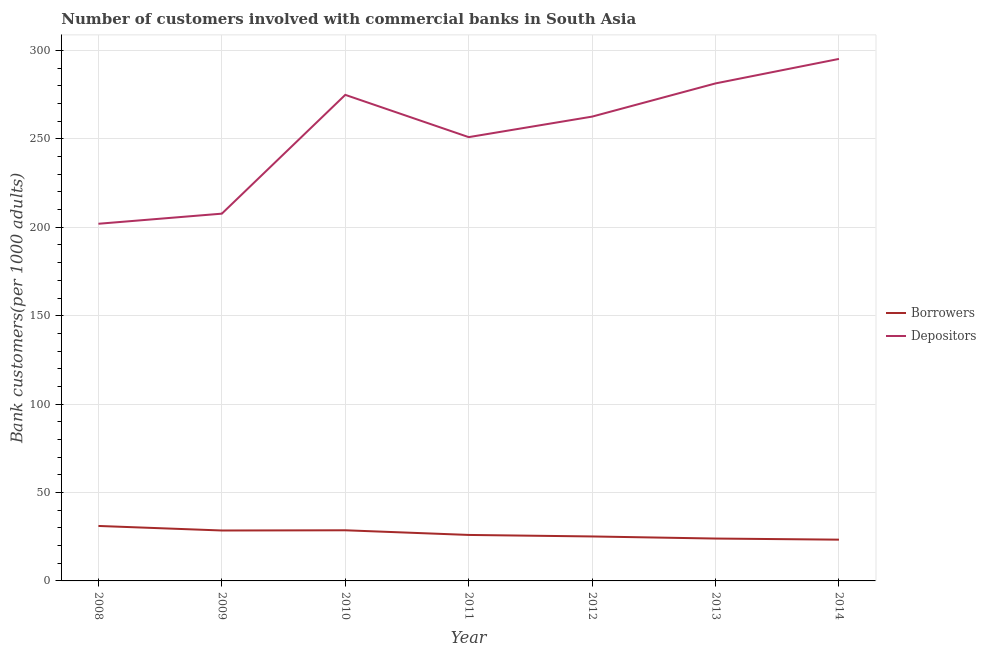How many different coloured lines are there?
Offer a terse response. 2. Is the number of lines equal to the number of legend labels?
Give a very brief answer. Yes. What is the number of borrowers in 2010?
Your answer should be compact. 28.64. Across all years, what is the maximum number of depositors?
Your answer should be compact. 295.23. Across all years, what is the minimum number of borrowers?
Provide a short and direct response. 23.34. In which year was the number of borrowers minimum?
Offer a very short reply. 2014. What is the total number of depositors in the graph?
Your answer should be compact. 1774.82. What is the difference between the number of borrowers in 2009 and that in 2014?
Your response must be concise. 5.18. What is the difference between the number of borrowers in 2011 and the number of depositors in 2014?
Provide a short and direct response. -269.22. What is the average number of borrowers per year?
Provide a short and direct response. 26.67. In the year 2013, what is the difference between the number of borrowers and number of depositors?
Keep it short and to the point. -257.41. What is the ratio of the number of depositors in 2011 to that in 2012?
Give a very brief answer. 0.96. Is the difference between the number of depositors in 2010 and 2012 greater than the difference between the number of borrowers in 2010 and 2012?
Your answer should be very brief. Yes. What is the difference between the highest and the second highest number of depositors?
Make the answer very short. 13.85. What is the difference between the highest and the lowest number of depositors?
Offer a terse response. 93.23. Is the sum of the number of borrowers in 2008 and 2009 greater than the maximum number of depositors across all years?
Keep it short and to the point. No. Is the number of depositors strictly less than the number of borrowers over the years?
Offer a very short reply. No. How many lines are there?
Offer a very short reply. 2. How many years are there in the graph?
Offer a very short reply. 7. How are the legend labels stacked?
Your answer should be compact. Vertical. What is the title of the graph?
Ensure brevity in your answer.  Number of customers involved with commercial banks in South Asia. Does "Male" appear as one of the legend labels in the graph?
Offer a terse response. No. What is the label or title of the Y-axis?
Provide a succinct answer. Bank customers(per 1000 adults). What is the Bank customers(per 1000 adults) in Borrowers in 2008?
Your answer should be compact. 31.09. What is the Bank customers(per 1000 adults) of Depositors in 2008?
Provide a short and direct response. 202. What is the Bank customers(per 1000 adults) of Borrowers in 2009?
Make the answer very short. 28.52. What is the Bank customers(per 1000 adults) of Depositors in 2009?
Your response must be concise. 207.71. What is the Bank customers(per 1000 adults) of Borrowers in 2010?
Offer a very short reply. 28.64. What is the Bank customers(per 1000 adults) in Depositors in 2010?
Provide a succinct answer. 274.9. What is the Bank customers(per 1000 adults) in Borrowers in 2011?
Offer a very short reply. 26.01. What is the Bank customers(per 1000 adults) in Depositors in 2011?
Offer a very short reply. 250.99. What is the Bank customers(per 1000 adults) of Borrowers in 2012?
Provide a short and direct response. 25.15. What is the Bank customers(per 1000 adults) of Depositors in 2012?
Your answer should be very brief. 262.6. What is the Bank customers(per 1000 adults) of Borrowers in 2013?
Make the answer very short. 23.97. What is the Bank customers(per 1000 adults) in Depositors in 2013?
Provide a succinct answer. 281.38. What is the Bank customers(per 1000 adults) in Borrowers in 2014?
Keep it short and to the point. 23.34. What is the Bank customers(per 1000 adults) of Depositors in 2014?
Ensure brevity in your answer.  295.23. Across all years, what is the maximum Bank customers(per 1000 adults) of Borrowers?
Give a very brief answer. 31.09. Across all years, what is the maximum Bank customers(per 1000 adults) in Depositors?
Ensure brevity in your answer.  295.23. Across all years, what is the minimum Bank customers(per 1000 adults) in Borrowers?
Ensure brevity in your answer.  23.34. Across all years, what is the minimum Bank customers(per 1000 adults) of Depositors?
Offer a very short reply. 202. What is the total Bank customers(per 1000 adults) in Borrowers in the graph?
Your response must be concise. 186.72. What is the total Bank customers(per 1000 adults) of Depositors in the graph?
Offer a very short reply. 1774.82. What is the difference between the Bank customers(per 1000 adults) in Borrowers in 2008 and that in 2009?
Offer a very short reply. 2.57. What is the difference between the Bank customers(per 1000 adults) of Depositors in 2008 and that in 2009?
Keep it short and to the point. -5.71. What is the difference between the Bank customers(per 1000 adults) of Borrowers in 2008 and that in 2010?
Provide a short and direct response. 2.45. What is the difference between the Bank customers(per 1000 adults) of Depositors in 2008 and that in 2010?
Your response must be concise. -72.91. What is the difference between the Bank customers(per 1000 adults) of Borrowers in 2008 and that in 2011?
Keep it short and to the point. 5.08. What is the difference between the Bank customers(per 1000 adults) of Depositors in 2008 and that in 2011?
Your response must be concise. -49. What is the difference between the Bank customers(per 1000 adults) of Borrowers in 2008 and that in 2012?
Your answer should be very brief. 5.94. What is the difference between the Bank customers(per 1000 adults) in Depositors in 2008 and that in 2012?
Your answer should be compact. -60.6. What is the difference between the Bank customers(per 1000 adults) of Borrowers in 2008 and that in 2013?
Ensure brevity in your answer.  7.13. What is the difference between the Bank customers(per 1000 adults) of Depositors in 2008 and that in 2013?
Offer a terse response. -79.38. What is the difference between the Bank customers(per 1000 adults) in Borrowers in 2008 and that in 2014?
Your answer should be compact. 7.75. What is the difference between the Bank customers(per 1000 adults) in Depositors in 2008 and that in 2014?
Provide a succinct answer. -93.23. What is the difference between the Bank customers(per 1000 adults) of Borrowers in 2009 and that in 2010?
Your answer should be compact. -0.12. What is the difference between the Bank customers(per 1000 adults) of Depositors in 2009 and that in 2010?
Keep it short and to the point. -67.19. What is the difference between the Bank customers(per 1000 adults) of Borrowers in 2009 and that in 2011?
Keep it short and to the point. 2.51. What is the difference between the Bank customers(per 1000 adults) of Depositors in 2009 and that in 2011?
Give a very brief answer. -43.28. What is the difference between the Bank customers(per 1000 adults) in Borrowers in 2009 and that in 2012?
Offer a very short reply. 3.37. What is the difference between the Bank customers(per 1000 adults) in Depositors in 2009 and that in 2012?
Keep it short and to the point. -54.89. What is the difference between the Bank customers(per 1000 adults) of Borrowers in 2009 and that in 2013?
Give a very brief answer. 4.55. What is the difference between the Bank customers(per 1000 adults) of Depositors in 2009 and that in 2013?
Your answer should be compact. -73.67. What is the difference between the Bank customers(per 1000 adults) in Borrowers in 2009 and that in 2014?
Offer a terse response. 5.18. What is the difference between the Bank customers(per 1000 adults) in Depositors in 2009 and that in 2014?
Provide a succinct answer. -87.52. What is the difference between the Bank customers(per 1000 adults) of Borrowers in 2010 and that in 2011?
Make the answer very short. 2.63. What is the difference between the Bank customers(per 1000 adults) in Depositors in 2010 and that in 2011?
Provide a succinct answer. 23.91. What is the difference between the Bank customers(per 1000 adults) in Borrowers in 2010 and that in 2012?
Your answer should be very brief. 3.49. What is the difference between the Bank customers(per 1000 adults) in Depositors in 2010 and that in 2012?
Keep it short and to the point. 12.31. What is the difference between the Bank customers(per 1000 adults) in Borrowers in 2010 and that in 2013?
Your answer should be very brief. 4.68. What is the difference between the Bank customers(per 1000 adults) of Depositors in 2010 and that in 2013?
Give a very brief answer. -6.48. What is the difference between the Bank customers(per 1000 adults) of Borrowers in 2010 and that in 2014?
Provide a succinct answer. 5.3. What is the difference between the Bank customers(per 1000 adults) in Depositors in 2010 and that in 2014?
Give a very brief answer. -20.33. What is the difference between the Bank customers(per 1000 adults) in Borrowers in 2011 and that in 2012?
Provide a short and direct response. 0.86. What is the difference between the Bank customers(per 1000 adults) in Depositors in 2011 and that in 2012?
Offer a terse response. -11.61. What is the difference between the Bank customers(per 1000 adults) in Borrowers in 2011 and that in 2013?
Your response must be concise. 2.04. What is the difference between the Bank customers(per 1000 adults) in Depositors in 2011 and that in 2013?
Make the answer very short. -30.39. What is the difference between the Bank customers(per 1000 adults) in Borrowers in 2011 and that in 2014?
Ensure brevity in your answer.  2.67. What is the difference between the Bank customers(per 1000 adults) of Depositors in 2011 and that in 2014?
Provide a short and direct response. -44.24. What is the difference between the Bank customers(per 1000 adults) of Borrowers in 2012 and that in 2013?
Keep it short and to the point. 1.18. What is the difference between the Bank customers(per 1000 adults) in Depositors in 2012 and that in 2013?
Provide a short and direct response. -18.78. What is the difference between the Bank customers(per 1000 adults) in Borrowers in 2012 and that in 2014?
Your response must be concise. 1.81. What is the difference between the Bank customers(per 1000 adults) in Depositors in 2012 and that in 2014?
Make the answer very short. -32.63. What is the difference between the Bank customers(per 1000 adults) of Borrowers in 2013 and that in 2014?
Provide a succinct answer. 0.63. What is the difference between the Bank customers(per 1000 adults) of Depositors in 2013 and that in 2014?
Offer a terse response. -13.85. What is the difference between the Bank customers(per 1000 adults) in Borrowers in 2008 and the Bank customers(per 1000 adults) in Depositors in 2009?
Ensure brevity in your answer.  -176.62. What is the difference between the Bank customers(per 1000 adults) in Borrowers in 2008 and the Bank customers(per 1000 adults) in Depositors in 2010?
Your answer should be very brief. -243.81. What is the difference between the Bank customers(per 1000 adults) of Borrowers in 2008 and the Bank customers(per 1000 adults) of Depositors in 2011?
Your response must be concise. -219.9. What is the difference between the Bank customers(per 1000 adults) of Borrowers in 2008 and the Bank customers(per 1000 adults) of Depositors in 2012?
Give a very brief answer. -231.51. What is the difference between the Bank customers(per 1000 adults) of Borrowers in 2008 and the Bank customers(per 1000 adults) of Depositors in 2013?
Give a very brief answer. -250.29. What is the difference between the Bank customers(per 1000 adults) in Borrowers in 2008 and the Bank customers(per 1000 adults) in Depositors in 2014?
Offer a terse response. -264.14. What is the difference between the Bank customers(per 1000 adults) in Borrowers in 2009 and the Bank customers(per 1000 adults) in Depositors in 2010?
Your answer should be very brief. -246.38. What is the difference between the Bank customers(per 1000 adults) of Borrowers in 2009 and the Bank customers(per 1000 adults) of Depositors in 2011?
Give a very brief answer. -222.47. What is the difference between the Bank customers(per 1000 adults) in Borrowers in 2009 and the Bank customers(per 1000 adults) in Depositors in 2012?
Provide a succinct answer. -234.08. What is the difference between the Bank customers(per 1000 adults) in Borrowers in 2009 and the Bank customers(per 1000 adults) in Depositors in 2013?
Make the answer very short. -252.86. What is the difference between the Bank customers(per 1000 adults) of Borrowers in 2009 and the Bank customers(per 1000 adults) of Depositors in 2014?
Make the answer very short. -266.71. What is the difference between the Bank customers(per 1000 adults) of Borrowers in 2010 and the Bank customers(per 1000 adults) of Depositors in 2011?
Provide a succinct answer. -222.35. What is the difference between the Bank customers(per 1000 adults) in Borrowers in 2010 and the Bank customers(per 1000 adults) in Depositors in 2012?
Give a very brief answer. -233.96. What is the difference between the Bank customers(per 1000 adults) of Borrowers in 2010 and the Bank customers(per 1000 adults) of Depositors in 2013?
Your answer should be compact. -252.74. What is the difference between the Bank customers(per 1000 adults) in Borrowers in 2010 and the Bank customers(per 1000 adults) in Depositors in 2014?
Offer a very short reply. -266.59. What is the difference between the Bank customers(per 1000 adults) of Borrowers in 2011 and the Bank customers(per 1000 adults) of Depositors in 2012?
Provide a succinct answer. -236.59. What is the difference between the Bank customers(per 1000 adults) of Borrowers in 2011 and the Bank customers(per 1000 adults) of Depositors in 2013?
Provide a succinct answer. -255.37. What is the difference between the Bank customers(per 1000 adults) of Borrowers in 2011 and the Bank customers(per 1000 adults) of Depositors in 2014?
Offer a very short reply. -269.22. What is the difference between the Bank customers(per 1000 adults) of Borrowers in 2012 and the Bank customers(per 1000 adults) of Depositors in 2013?
Ensure brevity in your answer.  -256.23. What is the difference between the Bank customers(per 1000 adults) in Borrowers in 2012 and the Bank customers(per 1000 adults) in Depositors in 2014?
Make the answer very short. -270.08. What is the difference between the Bank customers(per 1000 adults) in Borrowers in 2013 and the Bank customers(per 1000 adults) in Depositors in 2014?
Ensure brevity in your answer.  -271.27. What is the average Bank customers(per 1000 adults) of Borrowers per year?
Keep it short and to the point. 26.67. What is the average Bank customers(per 1000 adults) in Depositors per year?
Provide a succinct answer. 253.55. In the year 2008, what is the difference between the Bank customers(per 1000 adults) in Borrowers and Bank customers(per 1000 adults) in Depositors?
Keep it short and to the point. -170.91. In the year 2009, what is the difference between the Bank customers(per 1000 adults) in Borrowers and Bank customers(per 1000 adults) in Depositors?
Provide a succinct answer. -179.19. In the year 2010, what is the difference between the Bank customers(per 1000 adults) of Borrowers and Bank customers(per 1000 adults) of Depositors?
Give a very brief answer. -246.26. In the year 2011, what is the difference between the Bank customers(per 1000 adults) of Borrowers and Bank customers(per 1000 adults) of Depositors?
Make the answer very short. -224.98. In the year 2012, what is the difference between the Bank customers(per 1000 adults) of Borrowers and Bank customers(per 1000 adults) of Depositors?
Keep it short and to the point. -237.45. In the year 2013, what is the difference between the Bank customers(per 1000 adults) of Borrowers and Bank customers(per 1000 adults) of Depositors?
Keep it short and to the point. -257.41. In the year 2014, what is the difference between the Bank customers(per 1000 adults) of Borrowers and Bank customers(per 1000 adults) of Depositors?
Offer a very short reply. -271.89. What is the ratio of the Bank customers(per 1000 adults) in Borrowers in 2008 to that in 2009?
Provide a short and direct response. 1.09. What is the ratio of the Bank customers(per 1000 adults) in Depositors in 2008 to that in 2009?
Provide a succinct answer. 0.97. What is the ratio of the Bank customers(per 1000 adults) in Borrowers in 2008 to that in 2010?
Provide a short and direct response. 1.09. What is the ratio of the Bank customers(per 1000 adults) of Depositors in 2008 to that in 2010?
Your response must be concise. 0.73. What is the ratio of the Bank customers(per 1000 adults) of Borrowers in 2008 to that in 2011?
Keep it short and to the point. 1.2. What is the ratio of the Bank customers(per 1000 adults) in Depositors in 2008 to that in 2011?
Provide a short and direct response. 0.8. What is the ratio of the Bank customers(per 1000 adults) in Borrowers in 2008 to that in 2012?
Offer a very short reply. 1.24. What is the ratio of the Bank customers(per 1000 adults) of Depositors in 2008 to that in 2012?
Ensure brevity in your answer.  0.77. What is the ratio of the Bank customers(per 1000 adults) of Borrowers in 2008 to that in 2013?
Provide a short and direct response. 1.3. What is the ratio of the Bank customers(per 1000 adults) in Depositors in 2008 to that in 2013?
Offer a terse response. 0.72. What is the ratio of the Bank customers(per 1000 adults) of Borrowers in 2008 to that in 2014?
Offer a very short reply. 1.33. What is the ratio of the Bank customers(per 1000 adults) in Depositors in 2008 to that in 2014?
Provide a short and direct response. 0.68. What is the ratio of the Bank customers(per 1000 adults) in Borrowers in 2009 to that in 2010?
Offer a terse response. 1. What is the ratio of the Bank customers(per 1000 adults) of Depositors in 2009 to that in 2010?
Provide a short and direct response. 0.76. What is the ratio of the Bank customers(per 1000 adults) of Borrowers in 2009 to that in 2011?
Keep it short and to the point. 1.1. What is the ratio of the Bank customers(per 1000 adults) in Depositors in 2009 to that in 2011?
Offer a terse response. 0.83. What is the ratio of the Bank customers(per 1000 adults) in Borrowers in 2009 to that in 2012?
Provide a short and direct response. 1.13. What is the ratio of the Bank customers(per 1000 adults) of Depositors in 2009 to that in 2012?
Give a very brief answer. 0.79. What is the ratio of the Bank customers(per 1000 adults) of Borrowers in 2009 to that in 2013?
Ensure brevity in your answer.  1.19. What is the ratio of the Bank customers(per 1000 adults) in Depositors in 2009 to that in 2013?
Give a very brief answer. 0.74. What is the ratio of the Bank customers(per 1000 adults) of Borrowers in 2009 to that in 2014?
Offer a very short reply. 1.22. What is the ratio of the Bank customers(per 1000 adults) of Depositors in 2009 to that in 2014?
Make the answer very short. 0.7. What is the ratio of the Bank customers(per 1000 adults) in Borrowers in 2010 to that in 2011?
Provide a succinct answer. 1.1. What is the ratio of the Bank customers(per 1000 adults) of Depositors in 2010 to that in 2011?
Your answer should be very brief. 1.1. What is the ratio of the Bank customers(per 1000 adults) in Borrowers in 2010 to that in 2012?
Your response must be concise. 1.14. What is the ratio of the Bank customers(per 1000 adults) in Depositors in 2010 to that in 2012?
Your answer should be compact. 1.05. What is the ratio of the Bank customers(per 1000 adults) in Borrowers in 2010 to that in 2013?
Offer a terse response. 1.2. What is the ratio of the Bank customers(per 1000 adults) of Depositors in 2010 to that in 2013?
Your answer should be compact. 0.98. What is the ratio of the Bank customers(per 1000 adults) of Borrowers in 2010 to that in 2014?
Provide a succinct answer. 1.23. What is the ratio of the Bank customers(per 1000 adults) of Depositors in 2010 to that in 2014?
Provide a succinct answer. 0.93. What is the ratio of the Bank customers(per 1000 adults) in Borrowers in 2011 to that in 2012?
Offer a very short reply. 1.03. What is the ratio of the Bank customers(per 1000 adults) in Depositors in 2011 to that in 2012?
Offer a very short reply. 0.96. What is the ratio of the Bank customers(per 1000 adults) of Borrowers in 2011 to that in 2013?
Provide a succinct answer. 1.09. What is the ratio of the Bank customers(per 1000 adults) of Depositors in 2011 to that in 2013?
Keep it short and to the point. 0.89. What is the ratio of the Bank customers(per 1000 adults) in Borrowers in 2011 to that in 2014?
Make the answer very short. 1.11. What is the ratio of the Bank customers(per 1000 adults) in Depositors in 2011 to that in 2014?
Offer a very short reply. 0.85. What is the ratio of the Bank customers(per 1000 adults) of Borrowers in 2012 to that in 2013?
Your response must be concise. 1.05. What is the ratio of the Bank customers(per 1000 adults) in Borrowers in 2012 to that in 2014?
Offer a very short reply. 1.08. What is the ratio of the Bank customers(per 1000 adults) of Depositors in 2012 to that in 2014?
Keep it short and to the point. 0.89. What is the ratio of the Bank customers(per 1000 adults) of Borrowers in 2013 to that in 2014?
Make the answer very short. 1.03. What is the ratio of the Bank customers(per 1000 adults) of Depositors in 2013 to that in 2014?
Give a very brief answer. 0.95. What is the difference between the highest and the second highest Bank customers(per 1000 adults) of Borrowers?
Your response must be concise. 2.45. What is the difference between the highest and the second highest Bank customers(per 1000 adults) in Depositors?
Give a very brief answer. 13.85. What is the difference between the highest and the lowest Bank customers(per 1000 adults) of Borrowers?
Make the answer very short. 7.75. What is the difference between the highest and the lowest Bank customers(per 1000 adults) in Depositors?
Provide a short and direct response. 93.23. 